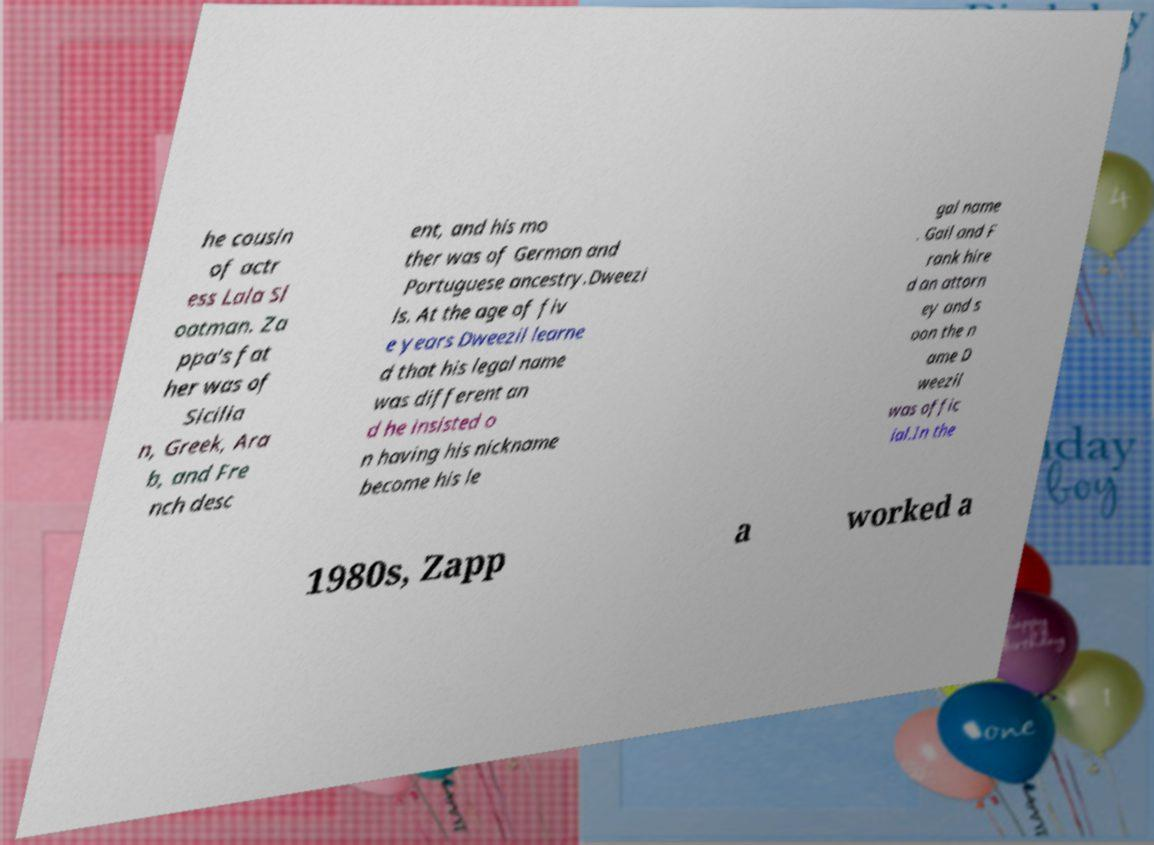There's text embedded in this image that I need extracted. Can you transcribe it verbatim? he cousin of actr ess Lala Sl oatman. Za ppa's fat her was of Sicilia n, Greek, Ara b, and Fre nch desc ent, and his mo ther was of German and Portuguese ancestry.Dweezi ls. At the age of fiv e years Dweezil learne d that his legal name was different an d he insisted o n having his nickname become his le gal name . Gail and F rank hire d an attorn ey and s oon the n ame D weezil was offic ial.In the 1980s, Zapp a worked a 